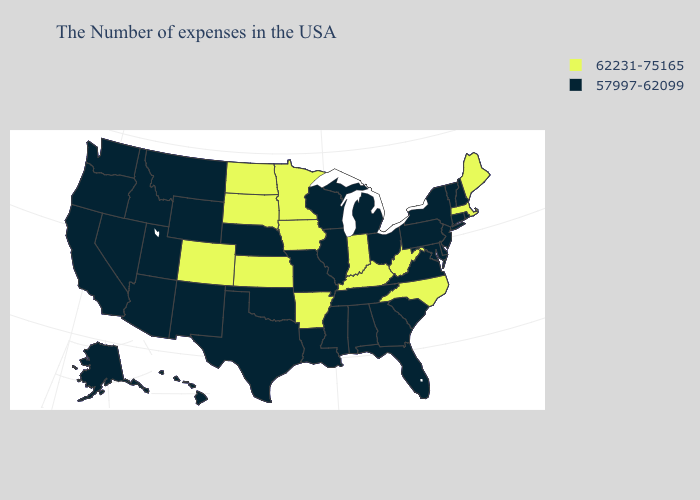What is the value of California?
Keep it brief. 57997-62099. What is the highest value in the South ?
Answer briefly. 62231-75165. What is the lowest value in the MidWest?
Be succinct. 57997-62099. Which states have the lowest value in the Northeast?
Concise answer only. Rhode Island, New Hampshire, Vermont, Connecticut, New York, New Jersey, Pennsylvania. Name the states that have a value in the range 62231-75165?
Concise answer only. Maine, Massachusetts, North Carolina, West Virginia, Kentucky, Indiana, Arkansas, Minnesota, Iowa, Kansas, South Dakota, North Dakota, Colorado. How many symbols are there in the legend?
Be succinct. 2. Does the first symbol in the legend represent the smallest category?
Concise answer only. No. What is the value of Rhode Island?
Give a very brief answer. 57997-62099. What is the value of North Dakota?
Concise answer only. 62231-75165. Name the states that have a value in the range 62231-75165?
Be succinct. Maine, Massachusetts, North Carolina, West Virginia, Kentucky, Indiana, Arkansas, Minnesota, Iowa, Kansas, South Dakota, North Dakota, Colorado. What is the highest value in states that border Nevada?
Give a very brief answer. 57997-62099. Does Maine have the lowest value in the USA?
Answer briefly. No. What is the value of Idaho?
Concise answer only. 57997-62099. Does Massachusetts have the lowest value in the Northeast?
Give a very brief answer. No. 